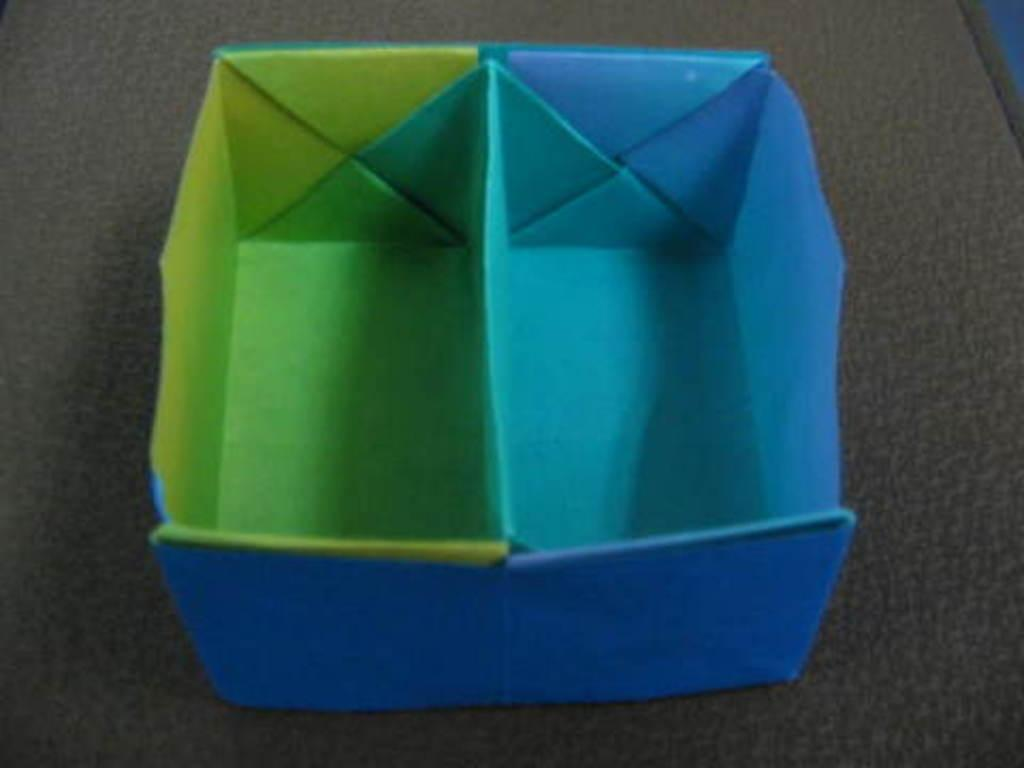What is the material used to make the bowl in the image? The bowl in the image is made with paper. Where is the paper bowl located? The paper bowl is placed on a table. What type of lead can be seen in the image? There is no lead present in the image. Is there a robin sitting on the table next to the paper bowl? No, there is no robin present in the image. 